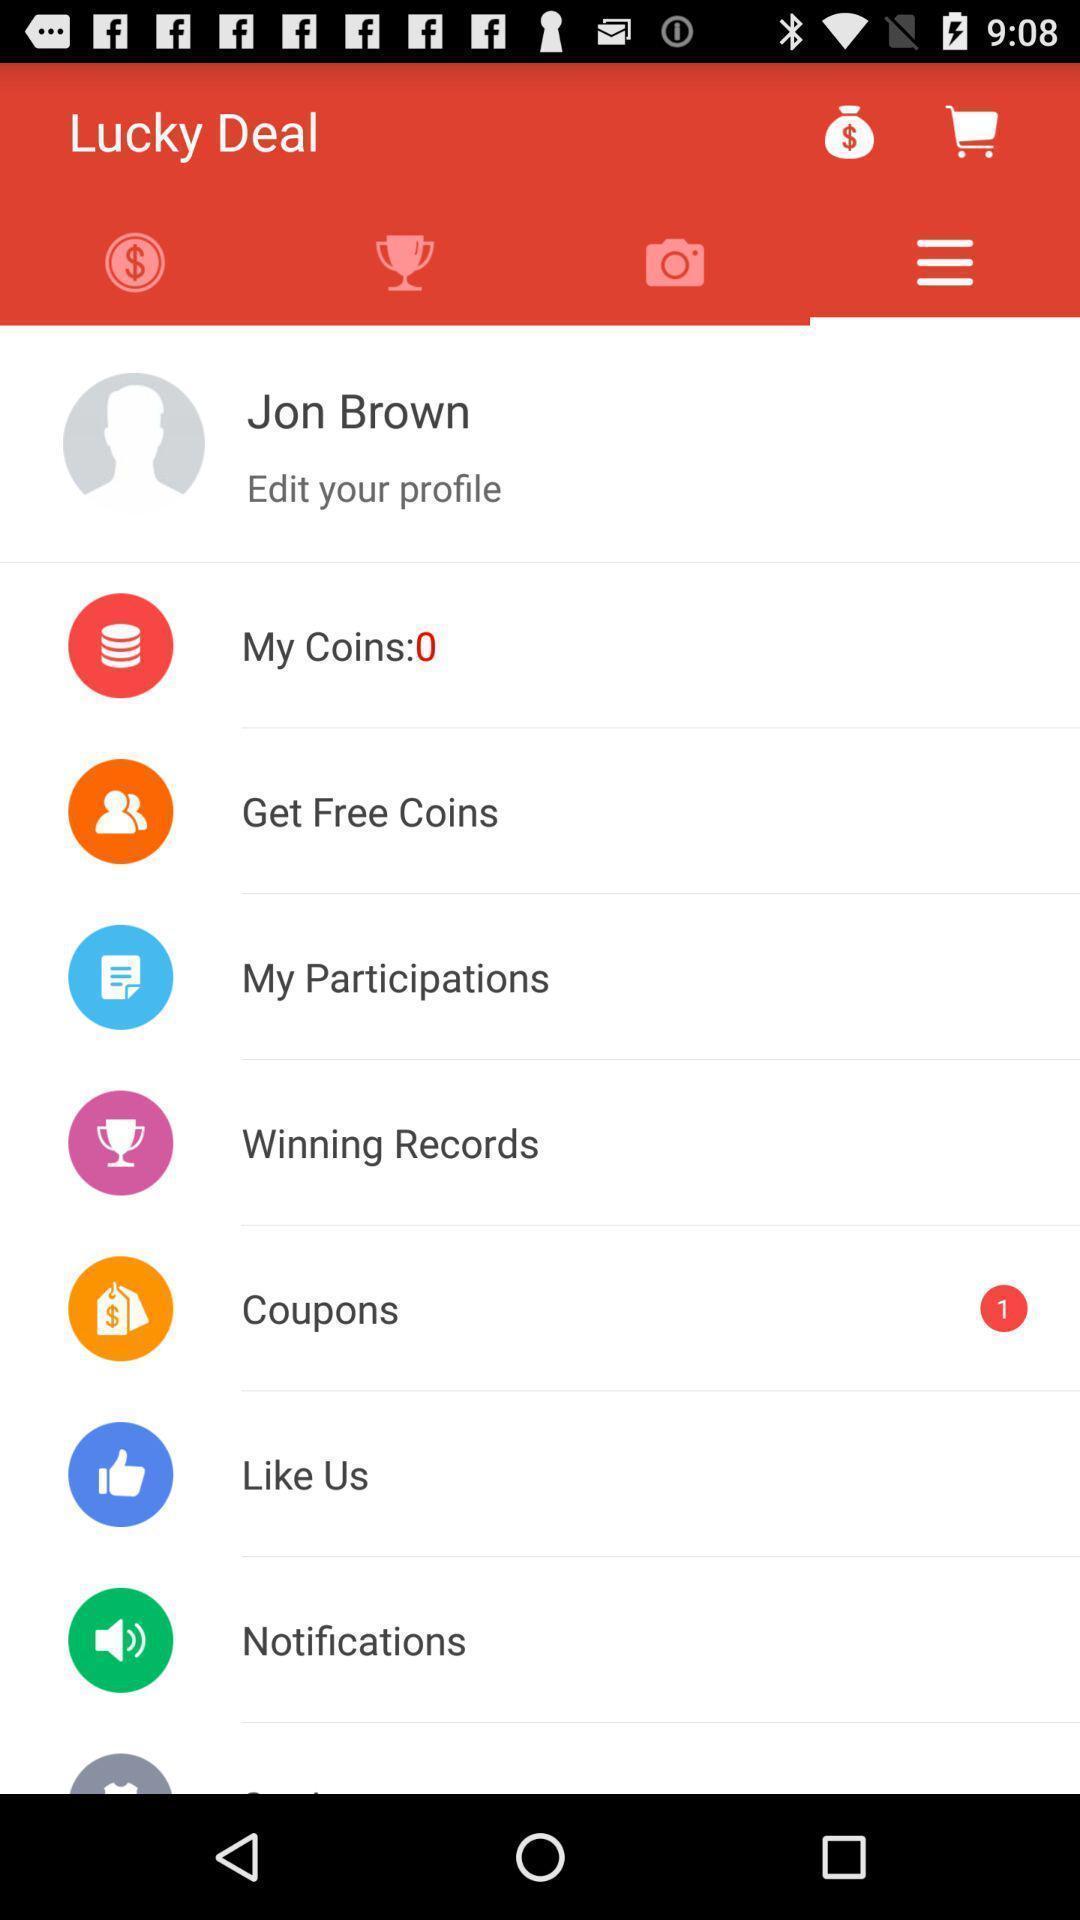Provide a textual representation of this image. Screen displaying menu page. 